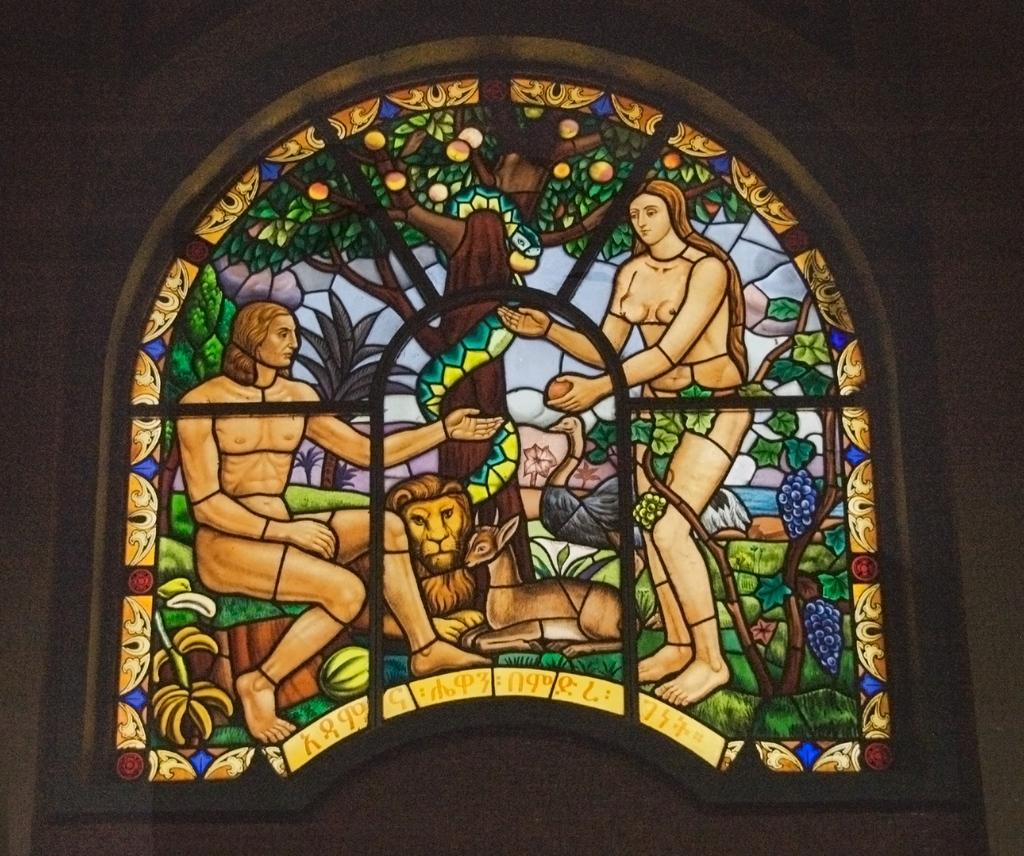What is the medium used to create the image? The image is a painting made on glass. How many persons are depicted in the painting? There are two persons in the painting. What animals are present in the painting? There is a lion and a deer in the painting. What other object can be seen in the painting? There is a tree in the painting. How is the painting presented in the image? The painting appears to be a window of a building. What type of dish is the cook preparing in the painting? There is no cook or dish preparation present in the painting; it features two persons, a lion, a deer, a tree, and a window-like appearance. 